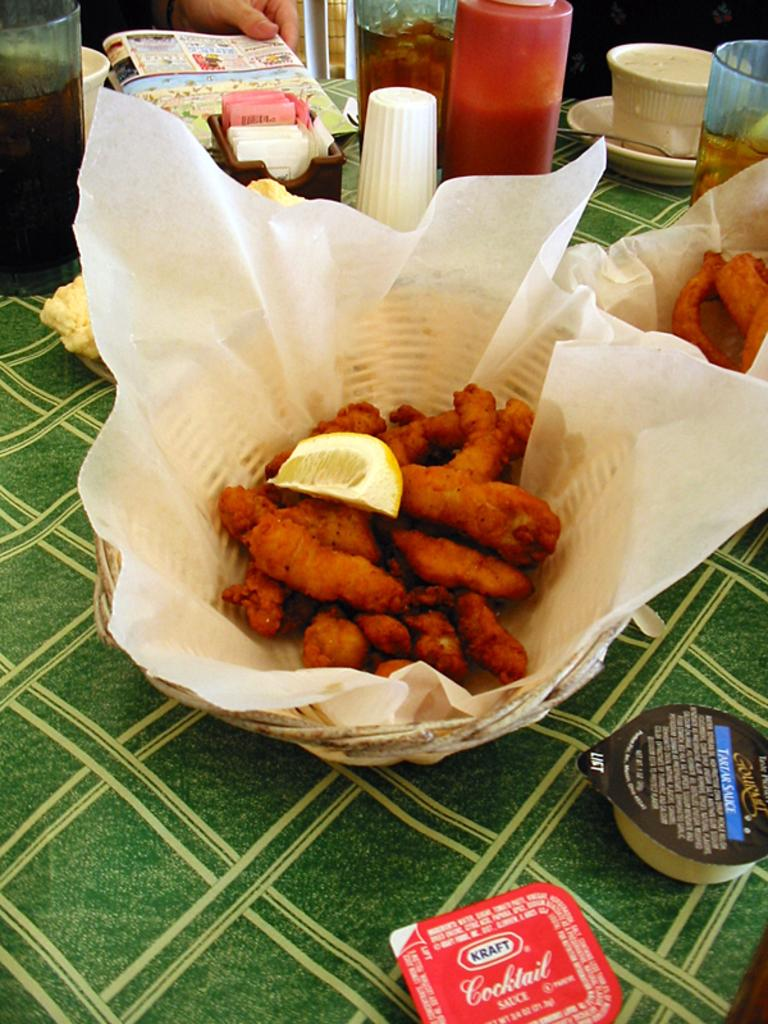<image>
Create a compact narrative representing the image presented. A red dipping sauce made by Kraft next to the basket of fish. 